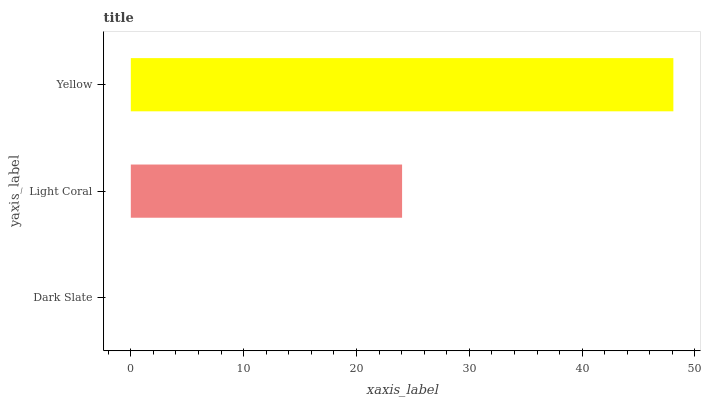Is Dark Slate the minimum?
Answer yes or no. Yes. Is Yellow the maximum?
Answer yes or no. Yes. Is Light Coral the minimum?
Answer yes or no. No. Is Light Coral the maximum?
Answer yes or no. No. Is Light Coral greater than Dark Slate?
Answer yes or no. Yes. Is Dark Slate less than Light Coral?
Answer yes or no. Yes. Is Dark Slate greater than Light Coral?
Answer yes or no. No. Is Light Coral less than Dark Slate?
Answer yes or no. No. Is Light Coral the high median?
Answer yes or no. Yes. Is Light Coral the low median?
Answer yes or no. Yes. Is Dark Slate the high median?
Answer yes or no. No. Is Yellow the low median?
Answer yes or no. No. 